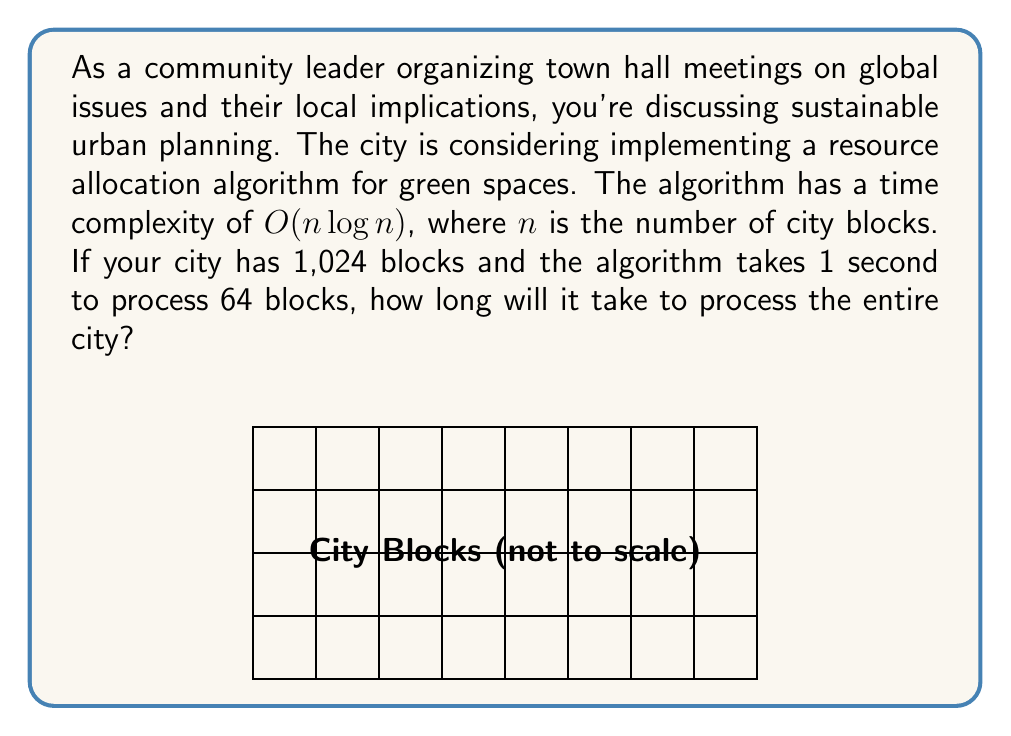Teach me how to tackle this problem. Let's approach this step-by-step:

1) We know that the time complexity is $O(n \log n)$, which means the time taken is proportional to $n \log n$.

2) We're given two pieces of information:
   - It takes 1 second to process 64 blocks
   - The city has 1,024 blocks

3) Let's call the time taken for $n$ blocks $T(n)$. We can write:

   $T(64) = 1$ second
   $T(64) = k \cdot 64 \log 64$, where $k$ is some constant

4) From this, we can find $k$:

   $1 = k \cdot 64 \log 64$
   $k = \frac{1}{64 \log 64} = \frac{1}{64 \cdot 6} = \frac{1}{384}$

5) Now, for 1,024 blocks:

   $T(1024) = k \cdot 1024 \log 1024$
   $= \frac{1}{384} \cdot 1024 \log 1024$
   $= \frac{1024}{384} \cdot \log 1024$
   $= \frac{8}{3} \cdot 10$
   $= \frac{80}{3}$
   $\approx 26.67$ seconds
Answer: $\frac{80}{3}$ seconds 